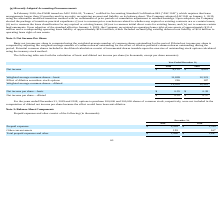From Travelzoo's financial document, What is the net income for 2019 and 2018 respectively? The document shows two values: $4,155 and $4,661 (in thousands). From the document: "Net income $ 4,155 $ 4,661 Net income $ 4,155 $ 4,661..." Also, How is basic net income per share computed? using the weighted-average number of common shares outstanding for the period.. The document states: "Basic net income per share is computed using the weighted-average number of common shares outstanding for the period. Diluted net income per share is..." Also, How is diluted net income per share computed? adjusting the weighted-average number of common shares outstanding for the effect of dilutive potential common shares outstanding during the period. The document states: "computed by adjusting the weighted-average number of common shares outstanding for the effect of dilutive potential common shares outstanding during t..." Also, can you calculate: What is the average basic net income per share for 2018 and 2019? To answer this question, I need to perform calculations using the financial data. The calculation is: (0.35+ 0.38)/2, which equals 0.36. This is based on the information: "Net income per share—basic $ 0.35 $ 0.38 Net income per share—basic $ 0.35 $ 0.38..." The key data points involved are: 0.35, 0.38. Also, can you calculate: What is the change in net income between 2018 and 2019? Based on the calculation: 4,155 -4,661 , the result is -506 (in thousands). This is based on the information: "Net income $ 4,155 $ 4,661 Net income $ 4,155 $ 4,661..." The key data points involved are: 4,155, 4,661. Additionally, Which year has a higher amount of net income? According to the financial document, 2018. The relevant text states: "2019 2018..." 